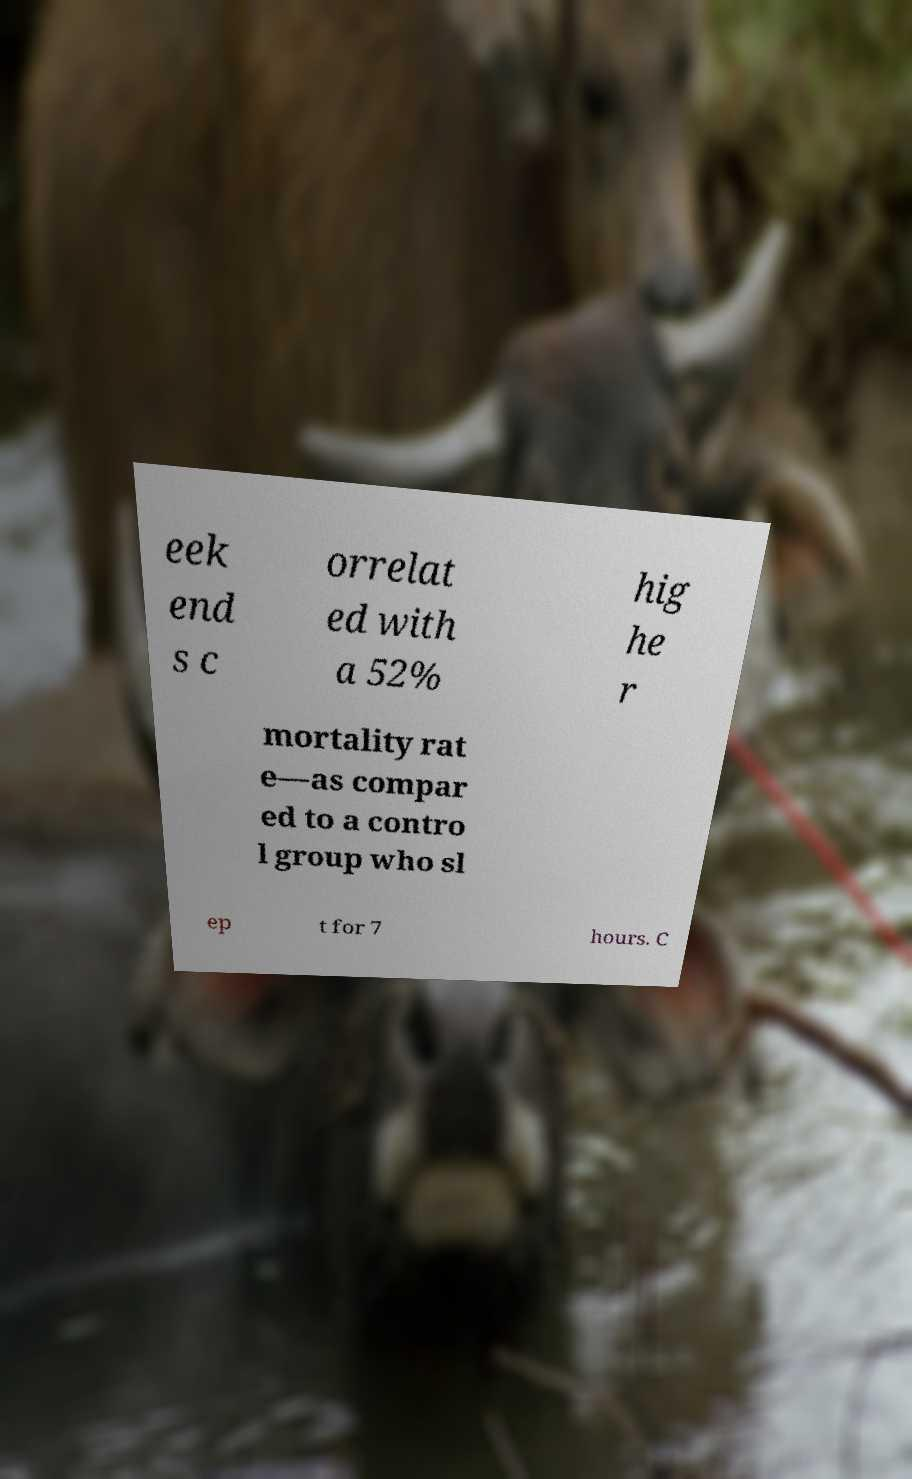Can you read and provide the text displayed in the image?This photo seems to have some interesting text. Can you extract and type it out for me? eek end s c orrelat ed with a 52% hig he r mortality rat e—as compar ed to a contro l group who sl ep t for 7 hours. C 